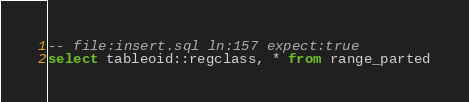<code> <loc_0><loc_0><loc_500><loc_500><_SQL_>-- file:insert.sql ln:157 expect:true
select tableoid::regclass, * from range_parted
</code> 